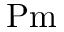<formula> <loc_0><loc_0><loc_500><loc_500>P m</formula> 